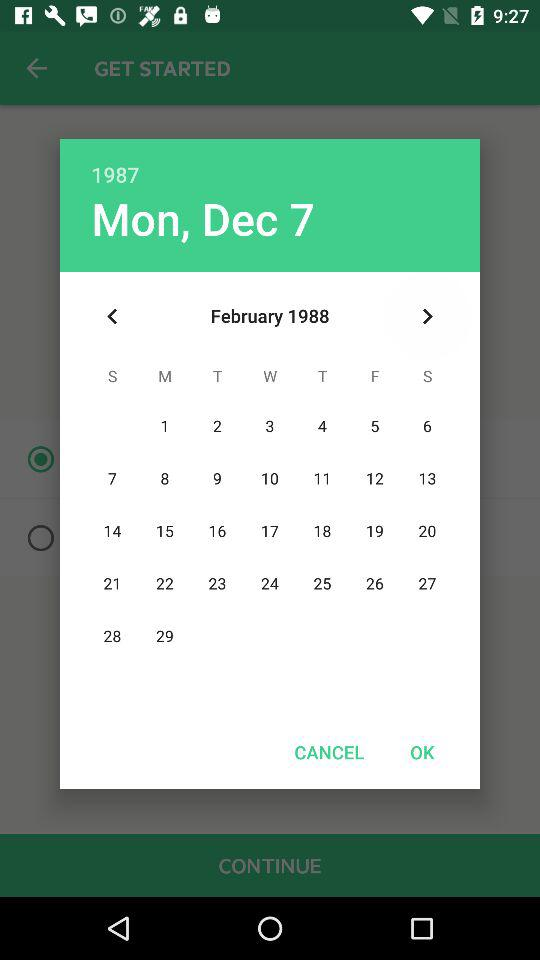Which month and year are displayed on the calendar? The displayed month and year are February and 1988 respectively. 